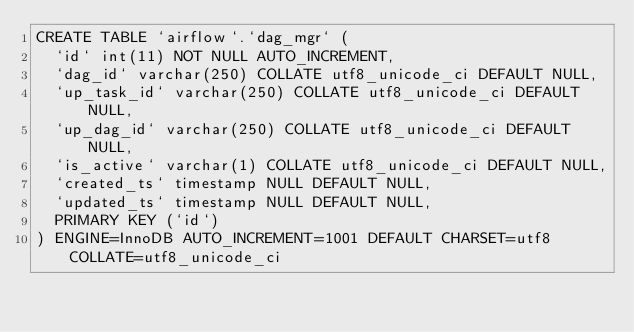<code> <loc_0><loc_0><loc_500><loc_500><_SQL_>CREATE TABLE `airflow`.`dag_mgr` (
  `id` int(11) NOT NULL AUTO_INCREMENT,
  `dag_id` varchar(250) COLLATE utf8_unicode_ci DEFAULT NULL,
  `up_task_id` varchar(250) COLLATE utf8_unicode_ci DEFAULT NULL,
  `up_dag_id` varchar(250) COLLATE utf8_unicode_ci DEFAULT NULL,
  `is_active` varchar(1) COLLATE utf8_unicode_ci DEFAULT NULL,
  `created_ts` timestamp NULL DEFAULT NULL,
  `updated_ts` timestamp NULL DEFAULT NULL,
  PRIMARY KEY (`id`)
) ENGINE=InnoDB AUTO_INCREMENT=1001 DEFAULT CHARSET=utf8 COLLATE=utf8_unicode_ci</code> 